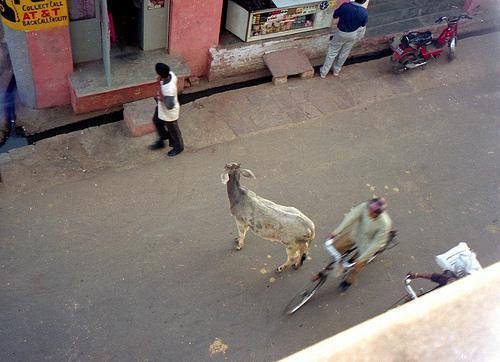How many goats are shown?
Give a very brief answer. 1. How many people are shown standing?
Give a very brief answer. 2. How many scooters are there?
Give a very brief answer. 1. 